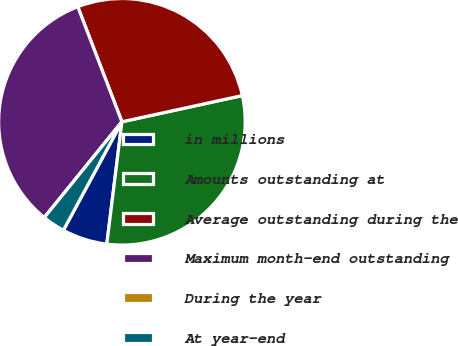<chart> <loc_0><loc_0><loc_500><loc_500><pie_chart><fcel>in millions<fcel>Amounts outstanding at<fcel>Average outstanding during the<fcel>Maximum month-end outstanding<fcel>During the year<fcel>At year-end<nl><fcel>5.92%<fcel>30.37%<fcel>27.41%<fcel>33.33%<fcel>0.0%<fcel>2.96%<nl></chart> 